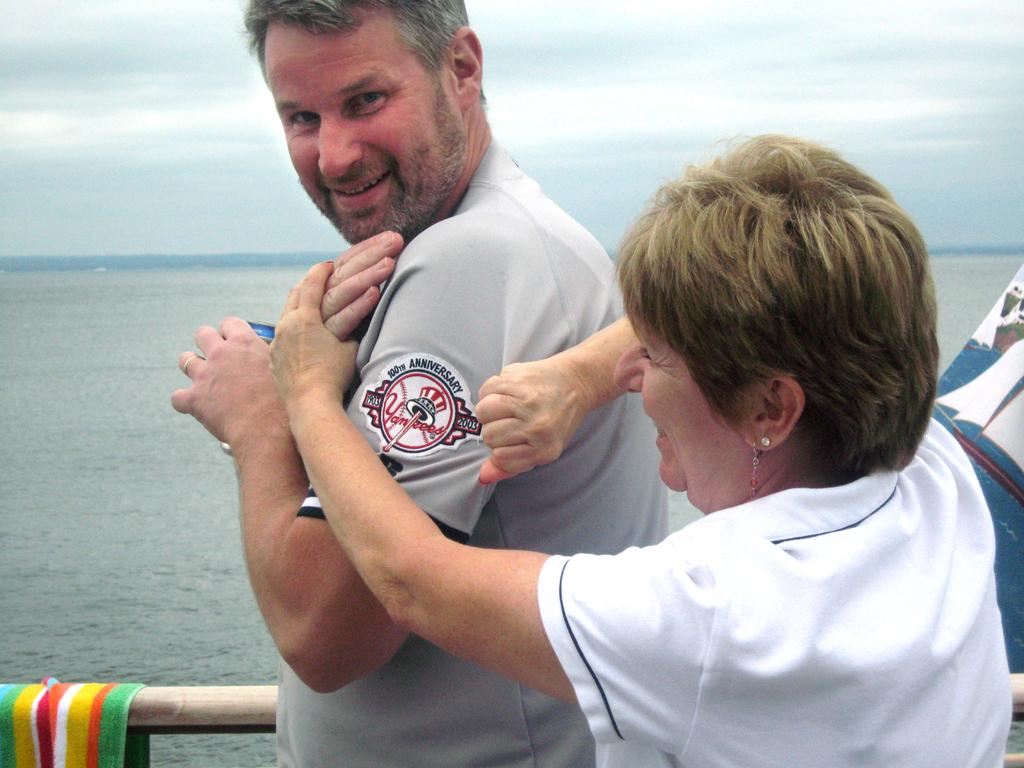Provide a one-sentence caption for the provided image. A woman is showing a 100th Anniversary  Yankees patch on a man's arm. 